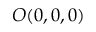<formula> <loc_0><loc_0><loc_500><loc_500>O ( 0 , 0 , 0 )</formula> 